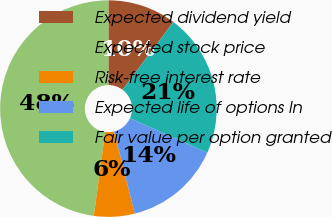Convert chart. <chart><loc_0><loc_0><loc_500><loc_500><pie_chart><fcel>Expected dividend yield<fcel>Expected stock price<fcel>Risk-free interest rate<fcel>Expected life of options In<fcel>Fair value per option granted<nl><fcel>10.24%<fcel>47.85%<fcel>6.06%<fcel>14.42%<fcel>21.43%<nl></chart> 